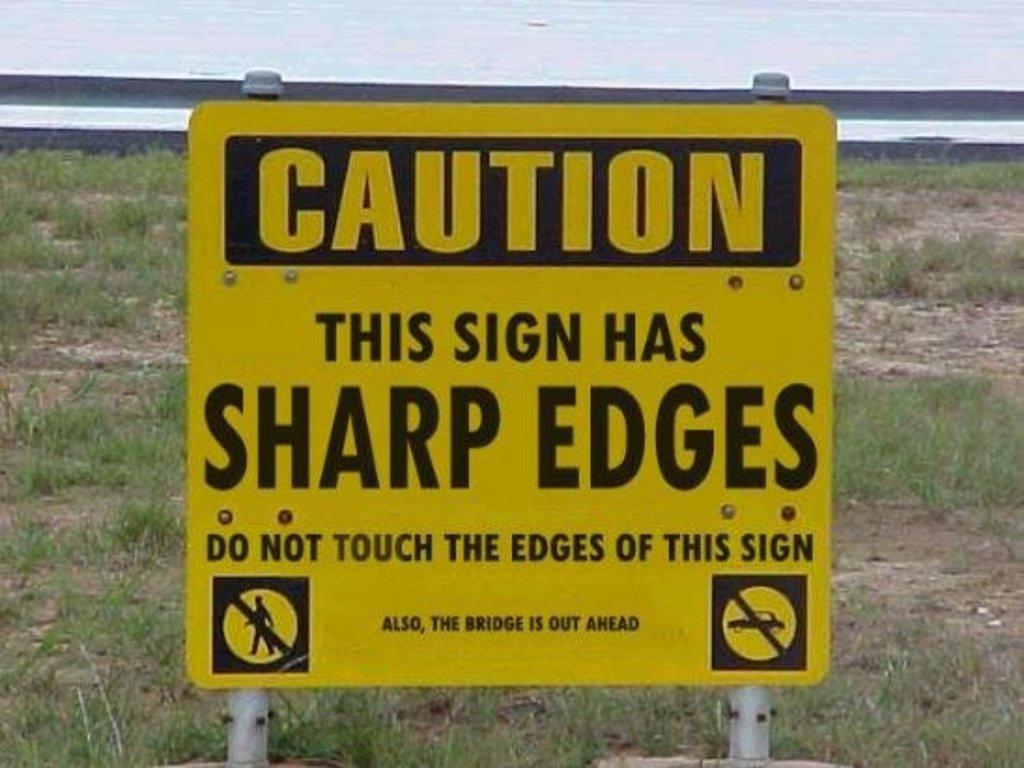What is the color of the sign board in the image? The sign board in the image is yellow. What can be found on the sign board? Something is written on the sign board. What type of natural environment is visible in the background of the image? There is grass visible in the background of the image. Are there any vests hanging from the sign board in the image? There are no vests present in the image. 